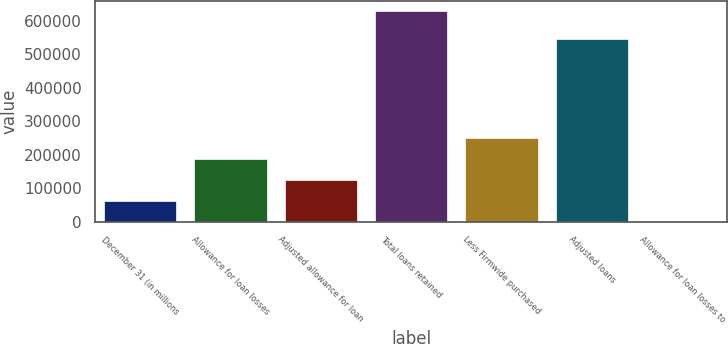<chart> <loc_0><loc_0><loc_500><loc_500><bar_chart><fcel>December 31 (in millions<fcel>Allowance for loan losses<fcel>Adjusted allowance for loan<fcel>Total loans retained<fcel>Less Firmwide purchased<fcel>Adjusted loans<fcel>Allowance for loan losses to<nl><fcel>62726.8<fcel>188169<fcel>125448<fcel>627218<fcel>250891<fcel>544836<fcel>5.51<nl></chart> 